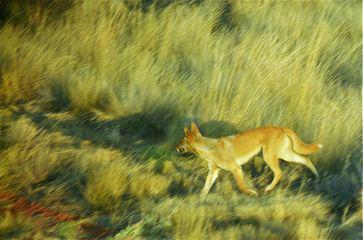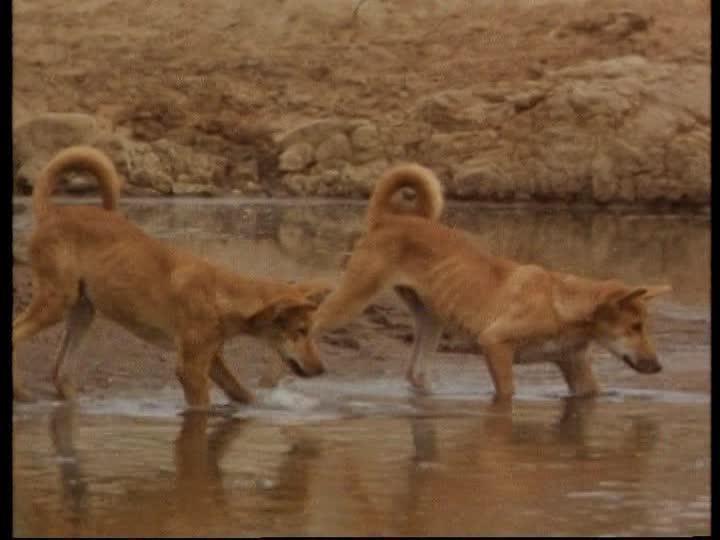The first image is the image on the left, the second image is the image on the right. For the images shown, is this caption "A kangaroo is being attacked by two coyotes." true? Answer yes or no. No. The first image is the image on the left, the second image is the image on the right. Considering the images on both sides, is "An upright kangaroo is flanked by two attacking dingos in the image on the left." valid? Answer yes or no. No. 